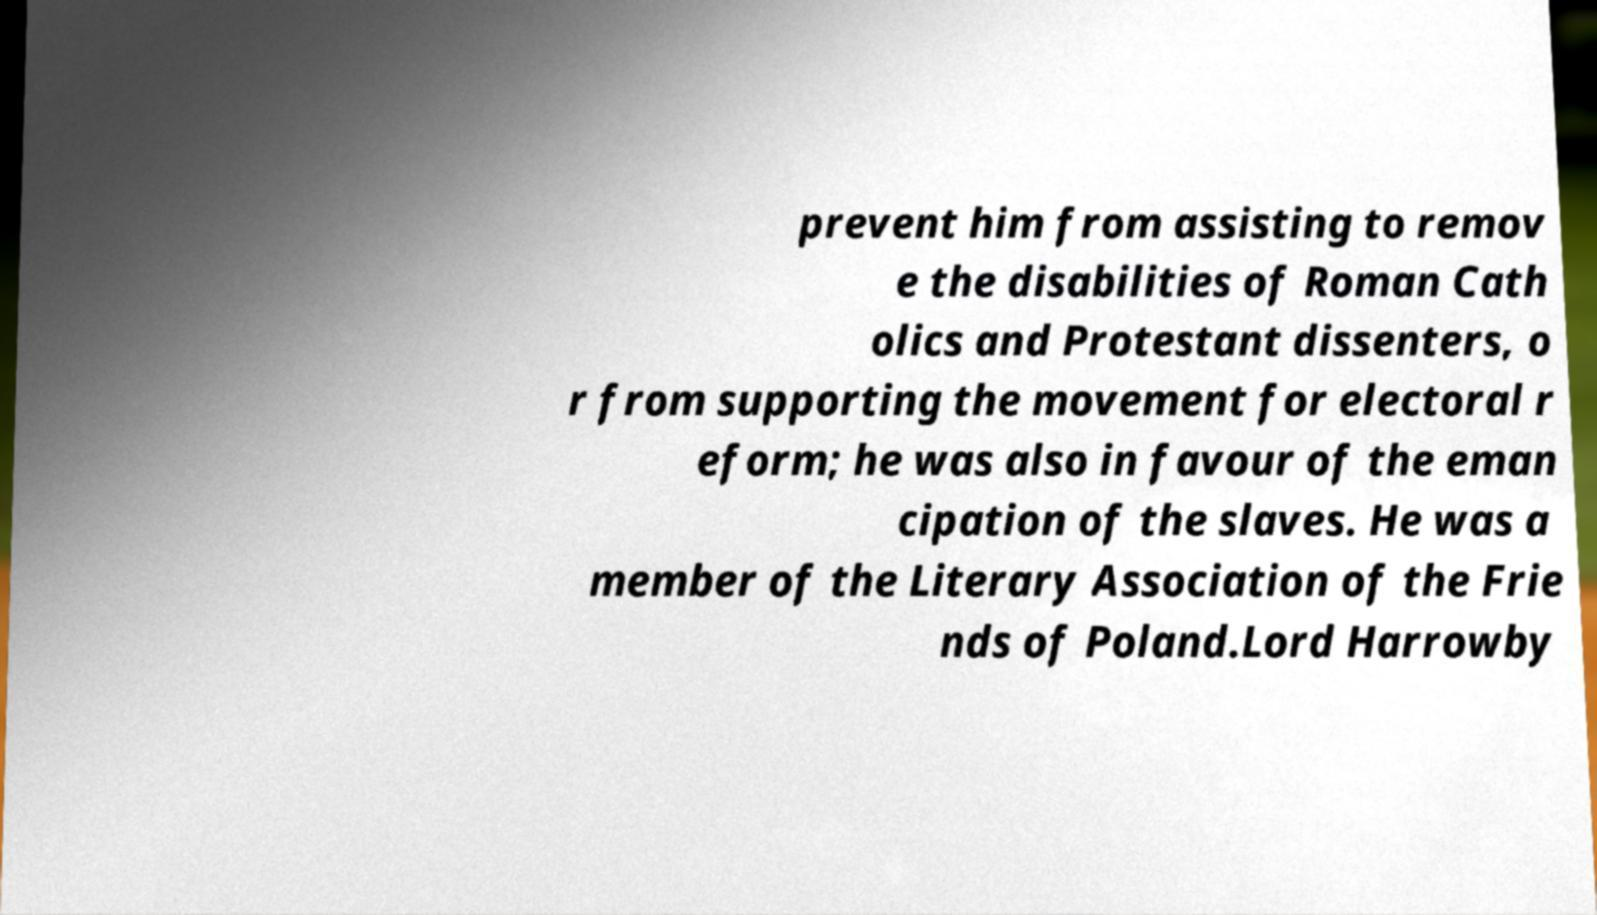I need the written content from this picture converted into text. Can you do that? prevent him from assisting to remov e the disabilities of Roman Cath olics and Protestant dissenters, o r from supporting the movement for electoral r eform; he was also in favour of the eman cipation of the slaves. He was a member of the Literary Association of the Frie nds of Poland.Lord Harrowby 